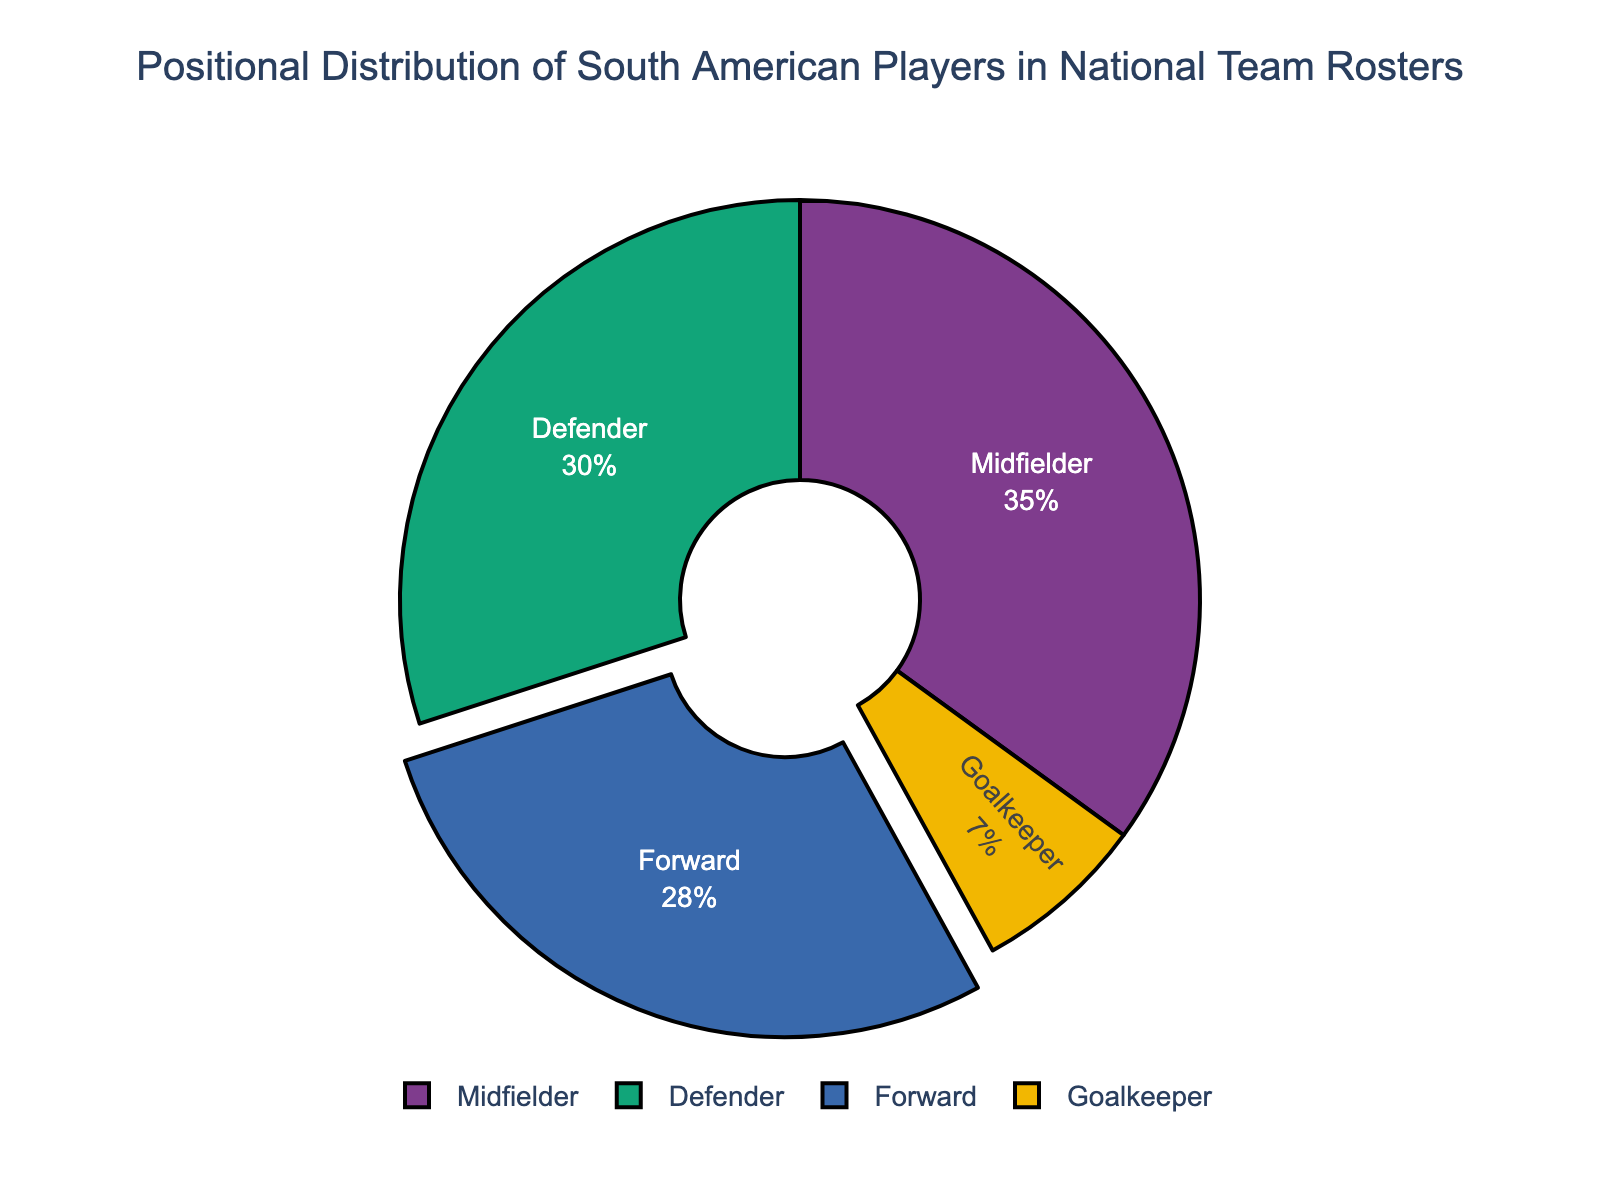Which position has the highest percentage of players? The chart shows the percentage distribution for each position. From the values, the position with the highest percentage is the one with the largest slice.
Answer: Midfielder What is the combined percentage of Forward and Defender positions? To get this value, add the percentage of Forward (28%) and Defender (30%) positions.
Answer: 58% How much greater is the percentage of Midfielders compared to Goalkeepers? Subtract the percentage of Goalkeepers (7%) from the percentage of Midfielders (35%).
Answer: 28% What is the difference in the percentage of Defenders and Forwards? Subtract the percentage of Forwards (28%) from the percentage of Defenders (30%).
Answer: 2% What position has the smallest percentage, and what is that percentage? The smallest percentage corresponds to the position with the smallest slice in the pie chart.
Answer: Goalkeeper, 7% If you combine the percentages of Goalkeepers and Defenders, would it be more or less than the percentage of Midfielders? Add the percentages of Goalkeepers (7%) and Defenders (30%) and compare it with Midfielders (35%). Since 7% + 30% = 37%, which is more.
Answer: More Which two positions have almost equal percentages? Compare the percentages for each position and find the ones that are closest. Defenders (30%) and Forwards (28%) have the most similar percentages.
Answer: Defender and Forward What is the average percentage of all positions? Calculate the average by adding all the percentages (28% + 35% + 30% + 7%) and dividing by the number of positions (4). (28 + 35 + 30 + 7) / 4 = 25%
Answer: 25% Which position's percentage would need an 8% increase to match the Midfielders' percentage? The Midfielders are at 35%, so find a position that is 8% less than this (35% - 8% = 27%). The Forwards are at 28%, close to being correct.
Answer: Forward 